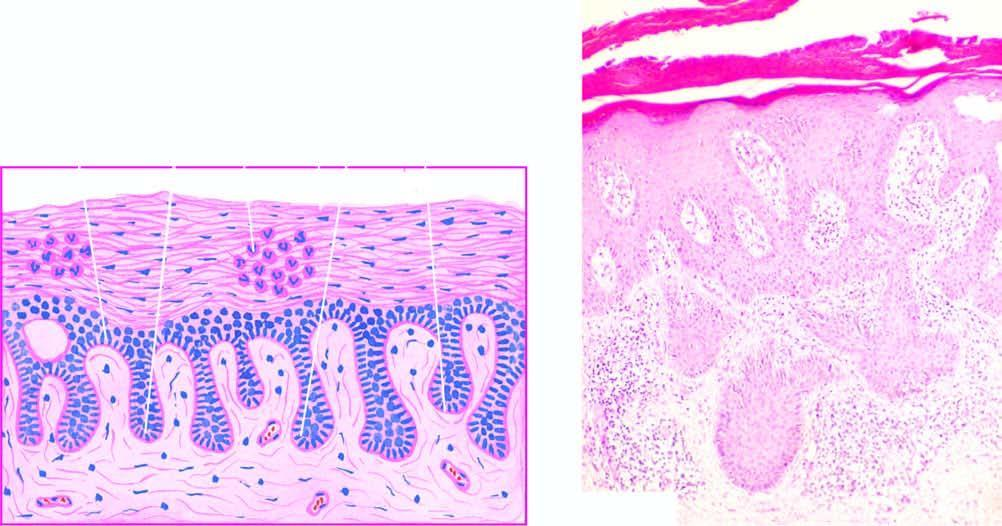what is there in the parakeratotic layer?
Answer the question using a single word or phrase. Marked parakeratosis with diagnostic munro microabscesses 